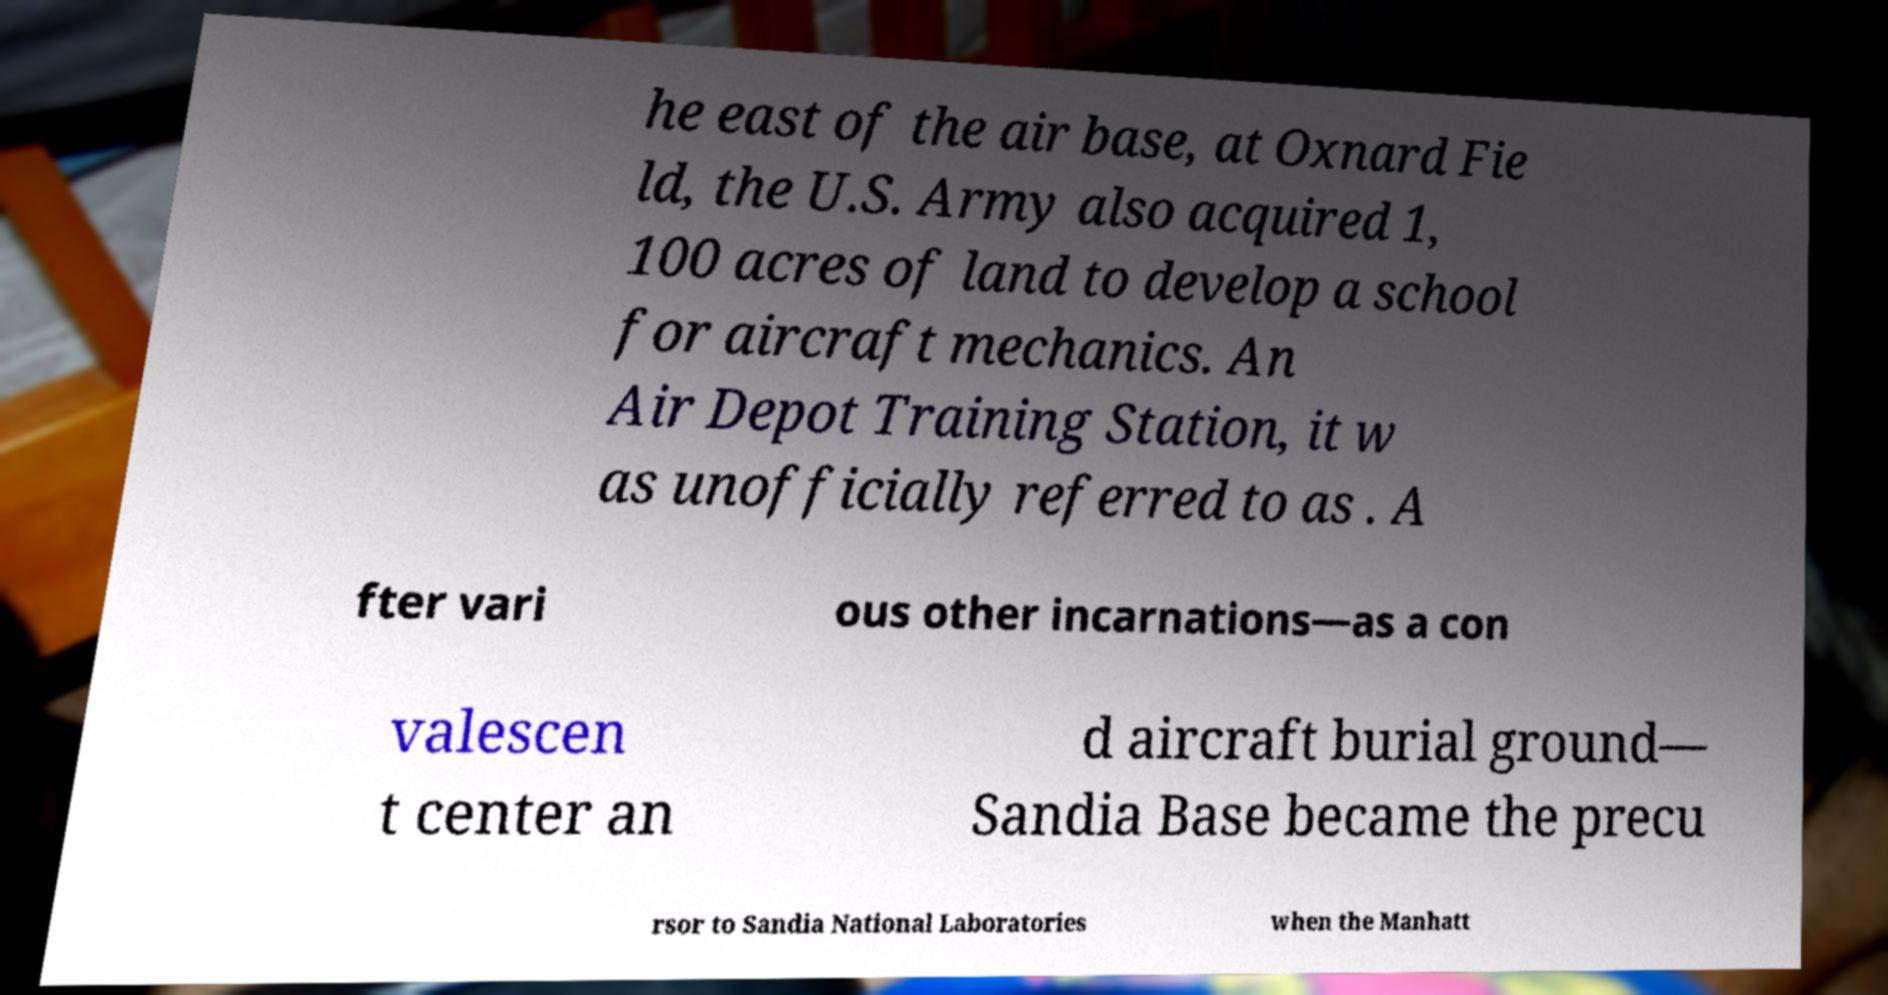For documentation purposes, I need the text within this image transcribed. Could you provide that? he east of the air base, at Oxnard Fie ld, the U.S. Army also acquired 1, 100 acres of land to develop a school for aircraft mechanics. An Air Depot Training Station, it w as unofficially referred to as . A fter vari ous other incarnations—as a con valescen t center an d aircraft burial ground— Sandia Base became the precu rsor to Sandia National Laboratories when the Manhatt 